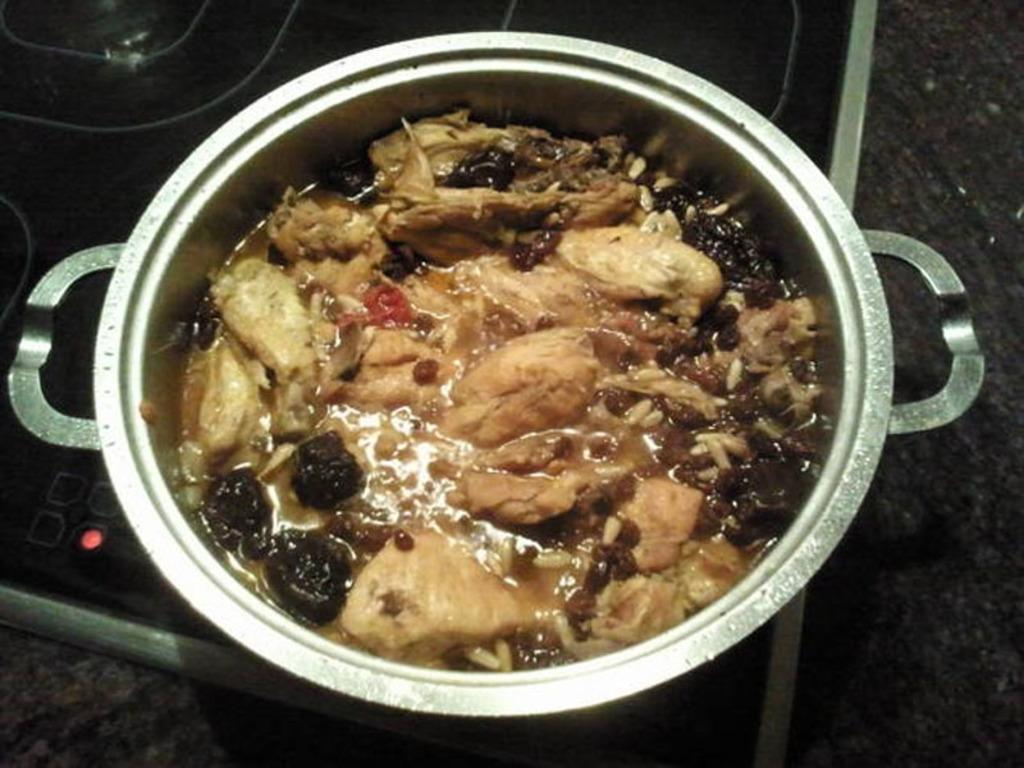In one or two sentences, can you explain what this image depicts? In this image we can see a food item is kept in steel a container on the induction stove. 